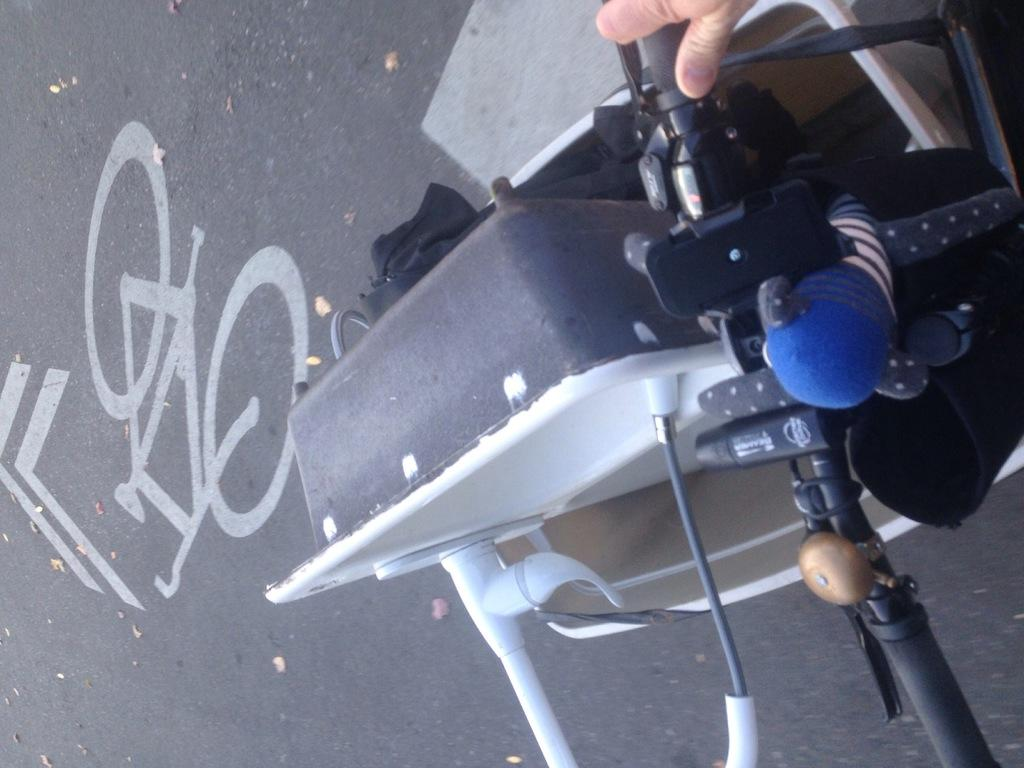What is the person in the image doing? There is a person cycling on the road in the image. What can be seen on the road besides the cyclist? There is a painting of a bicycle on the road. What is in the basket of the bicycle? There is an object in the basket of the bicycle. What type of teeth can be seen in the painting of the bicycle? There are no teeth visible in the image, as the painting is of a bicycle and not a living organism with teeth. 